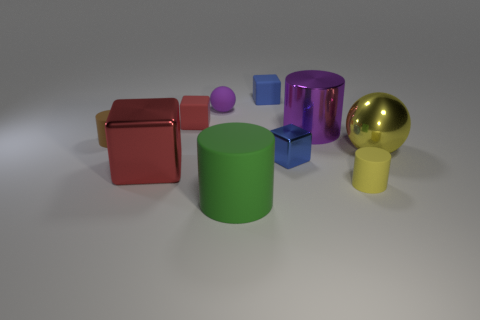Does the yellow matte object have the same shape as the yellow metal thing? No, the shapes are different. The yellow matte object is a cylinder, while the yellow metal thing resembles a sphere. 